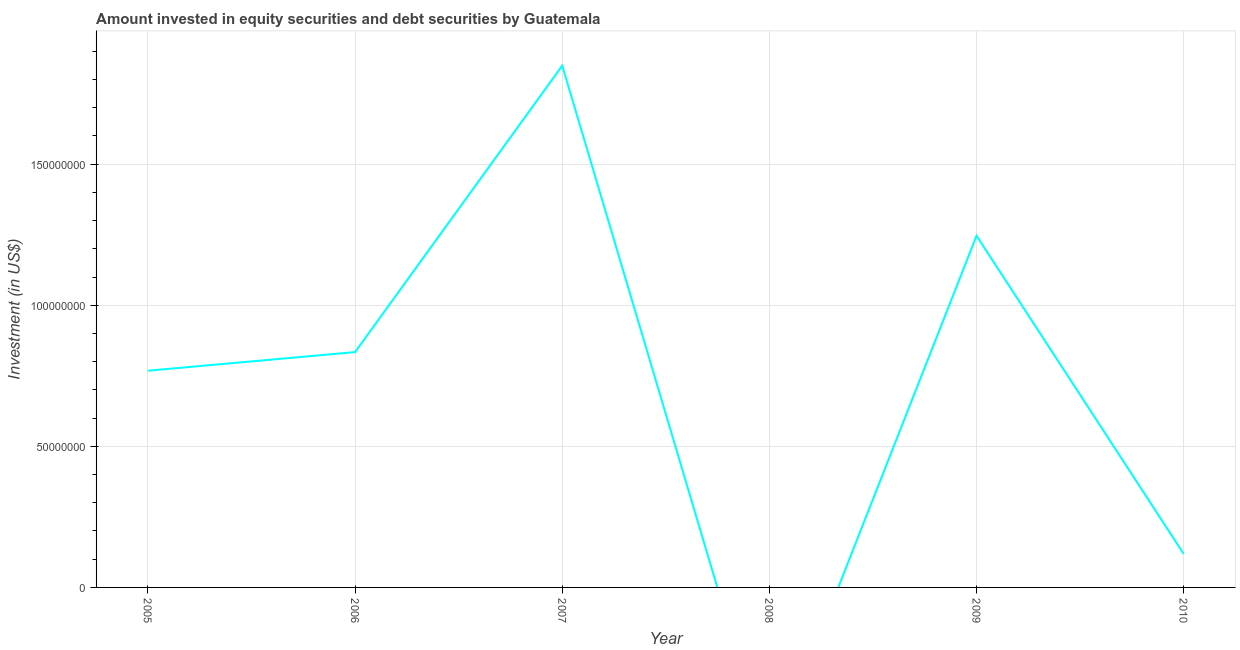What is the portfolio investment in 2010?
Make the answer very short. 1.19e+07. Across all years, what is the maximum portfolio investment?
Your response must be concise. 1.85e+08. Across all years, what is the minimum portfolio investment?
Your answer should be very brief. 0. In which year was the portfolio investment maximum?
Make the answer very short. 2007. What is the sum of the portfolio investment?
Provide a short and direct response. 4.82e+08. What is the difference between the portfolio investment in 2006 and 2007?
Provide a short and direct response. -1.02e+08. What is the average portfolio investment per year?
Provide a succinct answer. 8.03e+07. What is the median portfolio investment?
Offer a very short reply. 8.01e+07. What is the ratio of the portfolio investment in 2006 to that in 2007?
Provide a short and direct response. 0.45. Is the difference between the portfolio investment in 2006 and 2009 greater than the difference between any two years?
Provide a succinct answer. No. What is the difference between the highest and the second highest portfolio investment?
Provide a short and direct response. 6.03e+07. What is the difference between the highest and the lowest portfolio investment?
Give a very brief answer. 1.85e+08. In how many years, is the portfolio investment greater than the average portfolio investment taken over all years?
Your answer should be very brief. 3. How many lines are there?
Offer a very short reply. 1. How many years are there in the graph?
Offer a terse response. 6. What is the difference between two consecutive major ticks on the Y-axis?
Keep it short and to the point. 5.00e+07. Are the values on the major ticks of Y-axis written in scientific E-notation?
Keep it short and to the point. No. What is the title of the graph?
Give a very brief answer. Amount invested in equity securities and debt securities by Guatemala. What is the label or title of the X-axis?
Ensure brevity in your answer.  Year. What is the label or title of the Y-axis?
Provide a short and direct response. Investment (in US$). What is the Investment (in US$) in 2005?
Your answer should be compact. 7.68e+07. What is the Investment (in US$) in 2006?
Your answer should be compact. 8.34e+07. What is the Investment (in US$) of 2007?
Your answer should be very brief. 1.85e+08. What is the Investment (in US$) in 2009?
Ensure brevity in your answer.  1.25e+08. What is the Investment (in US$) in 2010?
Your response must be concise. 1.19e+07. What is the difference between the Investment (in US$) in 2005 and 2006?
Offer a very short reply. -6.60e+06. What is the difference between the Investment (in US$) in 2005 and 2007?
Ensure brevity in your answer.  -1.08e+08. What is the difference between the Investment (in US$) in 2005 and 2009?
Make the answer very short. -4.78e+07. What is the difference between the Investment (in US$) in 2005 and 2010?
Provide a succinct answer. 6.49e+07. What is the difference between the Investment (in US$) in 2006 and 2007?
Your answer should be compact. -1.02e+08. What is the difference between the Investment (in US$) in 2006 and 2009?
Offer a very short reply. -4.12e+07. What is the difference between the Investment (in US$) in 2006 and 2010?
Your response must be concise. 7.15e+07. What is the difference between the Investment (in US$) in 2007 and 2009?
Offer a terse response. 6.03e+07. What is the difference between the Investment (in US$) in 2007 and 2010?
Provide a succinct answer. 1.73e+08. What is the difference between the Investment (in US$) in 2009 and 2010?
Offer a terse response. 1.13e+08. What is the ratio of the Investment (in US$) in 2005 to that in 2006?
Your answer should be compact. 0.92. What is the ratio of the Investment (in US$) in 2005 to that in 2007?
Provide a short and direct response. 0.41. What is the ratio of the Investment (in US$) in 2005 to that in 2009?
Your answer should be compact. 0.62. What is the ratio of the Investment (in US$) in 2005 to that in 2010?
Make the answer very short. 6.47. What is the ratio of the Investment (in US$) in 2006 to that in 2007?
Provide a short and direct response. 0.45. What is the ratio of the Investment (in US$) in 2006 to that in 2009?
Provide a short and direct response. 0.67. What is the ratio of the Investment (in US$) in 2006 to that in 2010?
Give a very brief answer. 7.02. What is the ratio of the Investment (in US$) in 2007 to that in 2009?
Provide a succinct answer. 1.48. What is the ratio of the Investment (in US$) in 2007 to that in 2010?
Provide a short and direct response. 15.57. What is the ratio of the Investment (in US$) in 2009 to that in 2010?
Provide a succinct answer. 10.49. 